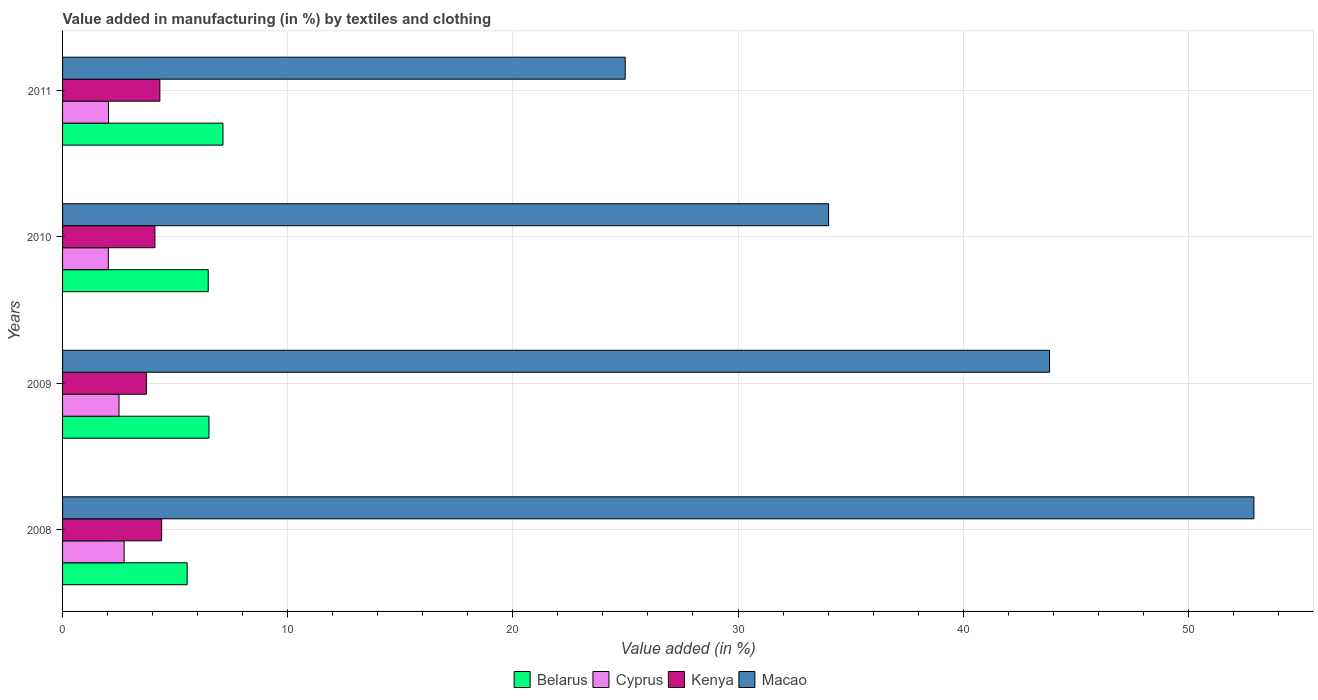How many different coloured bars are there?
Give a very brief answer. 4. Are the number of bars per tick equal to the number of legend labels?
Your response must be concise. Yes. What is the percentage of value added in manufacturing by textiles and clothing in Belarus in 2010?
Make the answer very short. 6.47. Across all years, what is the maximum percentage of value added in manufacturing by textiles and clothing in Kenya?
Your answer should be very brief. 4.4. Across all years, what is the minimum percentage of value added in manufacturing by textiles and clothing in Macao?
Offer a very short reply. 24.99. What is the total percentage of value added in manufacturing by textiles and clothing in Cyprus in the graph?
Your answer should be very brief. 9.31. What is the difference between the percentage of value added in manufacturing by textiles and clothing in Macao in 2009 and that in 2011?
Offer a terse response. 18.85. What is the difference between the percentage of value added in manufacturing by textiles and clothing in Macao in 2011 and the percentage of value added in manufacturing by textiles and clothing in Cyprus in 2008?
Offer a very short reply. 22.25. What is the average percentage of value added in manufacturing by textiles and clothing in Kenya per year?
Your response must be concise. 4.14. In the year 2010, what is the difference between the percentage of value added in manufacturing by textiles and clothing in Cyprus and percentage of value added in manufacturing by textiles and clothing in Macao?
Your answer should be very brief. -31.99. What is the ratio of the percentage of value added in manufacturing by textiles and clothing in Belarus in 2008 to that in 2010?
Ensure brevity in your answer.  0.86. Is the difference between the percentage of value added in manufacturing by textiles and clothing in Cyprus in 2010 and 2011 greater than the difference between the percentage of value added in manufacturing by textiles and clothing in Macao in 2010 and 2011?
Your answer should be compact. No. What is the difference between the highest and the second highest percentage of value added in manufacturing by textiles and clothing in Kenya?
Make the answer very short. 0.08. What is the difference between the highest and the lowest percentage of value added in manufacturing by textiles and clothing in Kenya?
Ensure brevity in your answer.  0.68. In how many years, is the percentage of value added in manufacturing by textiles and clothing in Cyprus greater than the average percentage of value added in manufacturing by textiles and clothing in Cyprus taken over all years?
Ensure brevity in your answer.  2. Is the sum of the percentage of value added in manufacturing by textiles and clothing in Kenya in 2010 and 2011 greater than the maximum percentage of value added in manufacturing by textiles and clothing in Belarus across all years?
Your answer should be very brief. Yes. What does the 4th bar from the top in 2010 represents?
Provide a short and direct response. Belarus. What does the 3rd bar from the bottom in 2010 represents?
Offer a very short reply. Kenya. Is it the case that in every year, the sum of the percentage of value added in manufacturing by textiles and clothing in Cyprus and percentage of value added in manufacturing by textiles and clothing in Macao is greater than the percentage of value added in manufacturing by textiles and clothing in Kenya?
Provide a succinct answer. Yes. How many years are there in the graph?
Your answer should be very brief. 4. What is the difference between two consecutive major ticks on the X-axis?
Offer a terse response. 10. Does the graph contain any zero values?
Offer a terse response. No. Does the graph contain grids?
Keep it short and to the point. Yes. Where does the legend appear in the graph?
Your response must be concise. Bottom center. How are the legend labels stacked?
Offer a terse response. Horizontal. What is the title of the graph?
Offer a very short reply. Value added in manufacturing (in %) by textiles and clothing. What is the label or title of the X-axis?
Provide a short and direct response. Value added (in %). What is the Value added (in %) of Belarus in 2008?
Keep it short and to the point. 5.53. What is the Value added (in %) of Cyprus in 2008?
Ensure brevity in your answer.  2.74. What is the Value added (in %) in Kenya in 2008?
Ensure brevity in your answer.  4.4. What is the Value added (in %) in Macao in 2008?
Ensure brevity in your answer.  52.92. What is the Value added (in %) of Belarus in 2009?
Give a very brief answer. 6.5. What is the Value added (in %) in Cyprus in 2009?
Your answer should be very brief. 2.51. What is the Value added (in %) of Kenya in 2009?
Offer a very short reply. 3.72. What is the Value added (in %) in Macao in 2009?
Make the answer very short. 43.84. What is the Value added (in %) of Belarus in 2010?
Your response must be concise. 6.47. What is the Value added (in %) of Cyprus in 2010?
Offer a very short reply. 2.03. What is the Value added (in %) in Kenya in 2010?
Keep it short and to the point. 4.1. What is the Value added (in %) of Macao in 2010?
Your answer should be compact. 34.02. What is the Value added (in %) of Belarus in 2011?
Your answer should be very brief. 7.12. What is the Value added (in %) in Cyprus in 2011?
Your response must be concise. 2.04. What is the Value added (in %) in Kenya in 2011?
Your answer should be compact. 4.32. What is the Value added (in %) in Macao in 2011?
Keep it short and to the point. 24.99. Across all years, what is the maximum Value added (in %) of Belarus?
Ensure brevity in your answer.  7.12. Across all years, what is the maximum Value added (in %) of Cyprus?
Offer a terse response. 2.74. Across all years, what is the maximum Value added (in %) of Kenya?
Ensure brevity in your answer.  4.4. Across all years, what is the maximum Value added (in %) of Macao?
Offer a very short reply. 52.92. Across all years, what is the minimum Value added (in %) in Belarus?
Your answer should be very brief. 5.53. Across all years, what is the minimum Value added (in %) of Cyprus?
Keep it short and to the point. 2.03. Across all years, what is the minimum Value added (in %) in Kenya?
Keep it short and to the point. 3.72. Across all years, what is the minimum Value added (in %) of Macao?
Offer a very short reply. 24.99. What is the total Value added (in %) in Belarus in the graph?
Make the answer very short. 25.63. What is the total Value added (in %) in Cyprus in the graph?
Provide a succinct answer. 9.31. What is the total Value added (in %) of Kenya in the graph?
Keep it short and to the point. 16.55. What is the total Value added (in %) of Macao in the graph?
Keep it short and to the point. 155.77. What is the difference between the Value added (in %) in Belarus in 2008 and that in 2009?
Provide a short and direct response. -0.97. What is the difference between the Value added (in %) of Cyprus in 2008 and that in 2009?
Provide a short and direct response. 0.23. What is the difference between the Value added (in %) in Kenya in 2008 and that in 2009?
Ensure brevity in your answer.  0.68. What is the difference between the Value added (in %) in Macao in 2008 and that in 2009?
Ensure brevity in your answer.  9.08. What is the difference between the Value added (in %) of Belarus in 2008 and that in 2010?
Make the answer very short. -0.94. What is the difference between the Value added (in %) of Cyprus in 2008 and that in 2010?
Your answer should be very brief. 0.7. What is the difference between the Value added (in %) of Kenya in 2008 and that in 2010?
Make the answer very short. 0.3. What is the difference between the Value added (in %) of Macao in 2008 and that in 2010?
Your response must be concise. 18.89. What is the difference between the Value added (in %) of Belarus in 2008 and that in 2011?
Make the answer very short. -1.59. What is the difference between the Value added (in %) in Cyprus in 2008 and that in 2011?
Provide a short and direct response. 0.69. What is the difference between the Value added (in %) of Kenya in 2008 and that in 2011?
Your answer should be compact. 0.08. What is the difference between the Value added (in %) of Macao in 2008 and that in 2011?
Your answer should be very brief. 27.93. What is the difference between the Value added (in %) of Belarus in 2009 and that in 2010?
Ensure brevity in your answer.  0.03. What is the difference between the Value added (in %) of Cyprus in 2009 and that in 2010?
Ensure brevity in your answer.  0.48. What is the difference between the Value added (in %) in Kenya in 2009 and that in 2010?
Make the answer very short. -0.38. What is the difference between the Value added (in %) in Macao in 2009 and that in 2010?
Provide a short and direct response. 9.82. What is the difference between the Value added (in %) of Belarus in 2009 and that in 2011?
Ensure brevity in your answer.  -0.62. What is the difference between the Value added (in %) in Cyprus in 2009 and that in 2011?
Your response must be concise. 0.47. What is the difference between the Value added (in %) in Kenya in 2009 and that in 2011?
Keep it short and to the point. -0.6. What is the difference between the Value added (in %) of Macao in 2009 and that in 2011?
Make the answer very short. 18.85. What is the difference between the Value added (in %) of Belarus in 2010 and that in 2011?
Ensure brevity in your answer.  -0.66. What is the difference between the Value added (in %) of Cyprus in 2010 and that in 2011?
Offer a terse response. -0.01. What is the difference between the Value added (in %) in Kenya in 2010 and that in 2011?
Offer a very short reply. -0.22. What is the difference between the Value added (in %) in Macao in 2010 and that in 2011?
Offer a terse response. 9.03. What is the difference between the Value added (in %) of Belarus in 2008 and the Value added (in %) of Cyprus in 2009?
Ensure brevity in your answer.  3.03. What is the difference between the Value added (in %) of Belarus in 2008 and the Value added (in %) of Kenya in 2009?
Your response must be concise. 1.81. What is the difference between the Value added (in %) in Belarus in 2008 and the Value added (in %) in Macao in 2009?
Provide a short and direct response. -38.31. What is the difference between the Value added (in %) of Cyprus in 2008 and the Value added (in %) of Kenya in 2009?
Your response must be concise. -0.99. What is the difference between the Value added (in %) of Cyprus in 2008 and the Value added (in %) of Macao in 2009?
Offer a very short reply. -41.1. What is the difference between the Value added (in %) in Kenya in 2008 and the Value added (in %) in Macao in 2009?
Ensure brevity in your answer.  -39.44. What is the difference between the Value added (in %) in Belarus in 2008 and the Value added (in %) in Cyprus in 2010?
Give a very brief answer. 3.5. What is the difference between the Value added (in %) of Belarus in 2008 and the Value added (in %) of Kenya in 2010?
Ensure brevity in your answer.  1.43. What is the difference between the Value added (in %) of Belarus in 2008 and the Value added (in %) of Macao in 2010?
Keep it short and to the point. -28.49. What is the difference between the Value added (in %) in Cyprus in 2008 and the Value added (in %) in Kenya in 2010?
Give a very brief answer. -1.37. What is the difference between the Value added (in %) of Cyprus in 2008 and the Value added (in %) of Macao in 2010?
Provide a succinct answer. -31.29. What is the difference between the Value added (in %) of Kenya in 2008 and the Value added (in %) of Macao in 2010?
Provide a succinct answer. -29.62. What is the difference between the Value added (in %) in Belarus in 2008 and the Value added (in %) in Cyprus in 2011?
Offer a terse response. 3.49. What is the difference between the Value added (in %) in Belarus in 2008 and the Value added (in %) in Kenya in 2011?
Offer a very short reply. 1.21. What is the difference between the Value added (in %) of Belarus in 2008 and the Value added (in %) of Macao in 2011?
Your response must be concise. -19.46. What is the difference between the Value added (in %) in Cyprus in 2008 and the Value added (in %) in Kenya in 2011?
Provide a succinct answer. -1.59. What is the difference between the Value added (in %) of Cyprus in 2008 and the Value added (in %) of Macao in 2011?
Provide a succinct answer. -22.25. What is the difference between the Value added (in %) of Kenya in 2008 and the Value added (in %) of Macao in 2011?
Ensure brevity in your answer.  -20.59. What is the difference between the Value added (in %) in Belarus in 2009 and the Value added (in %) in Cyprus in 2010?
Offer a terse response. 4.47. What is the difference between the Value added (in %) of Belarus in 2009 and the Value added (in %) of Kenya in 2010?
Your response must be concise. 2.4. What is the difference between the Value added (in %) in Belarus in 2009 and the Value added (in %) in Macao in 2010?
Your answer should be compact. -27.52. What is the difference between the Value added (in %) in Cyprus in 2009 and the Value added (in %) in Kenya in 2010?
Provide a short and direct response. -1.59. What is the difference between the Value added (in %) of Cyprus in 2009 and the Value added (in %) of Macao in 2010?
Offer a very short reply. -31.52. What is the difference between the Value added (in %) of Kenya in 2009 and the Value added (in %) of Macao in 2010?
Offer a very short reply. -30.3. What is the difference between the Value added (in %) in Belarus in 2009 and the Value added (in %) in Cyprus in 2011?
Ensure brevity in your answer.  4.46. What is the difference between the Value added (in %) of Belarus in 2009 and the Value added (in %) of Kenya in 2011?
Offer a terse response. 2.18. What is the difference between the Value added (in %) in Belarus in 2009 and the Value added (in %) in Macao in 2011?
Your answer should be very brief. -18.49. What is the difference between the Value added (in %) of Cyprus in 2009 and the Value added (in %) of Kenya in 2011?
Your answer should be compact. -1.81. What is the difference between the Value added (in %) in Cyprus in 2009 and the Value added (in %) in Macao in 2011?
Provide a short and direct response. -22.48. What is the difference between the Value added (in %) in Kenya in 2009 and the Value added (in %) in Macao in 2011?
Your answer should be very brief. -21.27. What is the difference between the Value added (in %) in Belarus in 2010 and the Value added (in %) in Cyprus in 2011?
Offer a very short reply. 4.43. What is the difference between the Value added (in %) of Belarus in 2010 and the Value added (in %) of Kenya in 2011?
Make the answer very short. 2.15. What is the difference between the Value added (in %) in Belarus in 2010 and the Value added (in %) in Macao in 2011?
Ensure brevity in your answer.  -18.52. What is the difference between the Value added (in %) of Cyprus in 2010 and the Value added (in %) of Kenya in 2011?
Offer a terse response. -2.29. What is the difference between the Value added (in %) in Cyprus in 2010 and the Value added (in %) in Macao in 2011?
Your answer should be very brief. -22.96. What is the difference between the Value added (in %) of Kenya in 2010 and the Value added (in %) of Macao in 2011?
Offer a very short reply. -20.89. What is the average Value added (in %) in Belarus per year?
Your response must be concise. 6.41. What is the average Value added (in %) of Cyprus per year?
Make the answer very short. 2.33. What is the average Value added (in %) in Kenya per year?
Give a very brief answer. 4.14. What is the average Value added (in %) of Macao per year?
Your answer should be very brief. 38.94. In the year 2008, what is the difference between the Value added (in %) of Belarus and Value added (in %) of Cyprus?
Offer a very short reply. 2.8. In the year 2008, what is the difference between the Value added (in %) of Belarus and Value added (in %) of Kenya?
Keep it short and to the point. 1.13. In the year 2008, what is the difference between the Value added (in %) of Belarus and Value added (in %) of Macao?
Make the answer very short. -47.38. In the year 2008, what is the difference between the Value added (in %) in Cyprus and Value added (in %) in Kenya?
Your response must be concise. -1.67. In the year 2008, what is the difference between the Value added (in %) in Cyprus and Value added (in %) in Macao?
Make the answer very short. -50.18. In the year 2008, what is the difference between the Value added (in %) in Kenya and Value added (in %) in Macao?
Keep it short and to the point. -48.51. In the year 2009, what is the difference between the Value added (in %) in Belarus and Value added (in %) in Cyprus?
Your answer should be compact. 4. In the year 2009, what is the difference between the Value added (in %) in Belarus and Value added (in %) in Kenya?
Give a very brief answer. 2.78. In the year 2009, what is the difference between the Value added (in %) of Belarus and Value added (in %) of Macao?
Ensure brevity in your answer.  -37.34. In the year 2009, what is the difference between the Value added (in %) of Cyprus and Value added (in %) of Kenya?
Ensure brevity in your answer.  -1.22. In the year 2009, what is the difference between the Value added (in %) in Cyprus and Value added (in %) in Macao?
Offer a terse response. -41.33. In the year 2009, what is the difference between the Value added (in %) in Kenya and Value added (in %) in Macao?
Ensure brevity in your answer.  -40.12. In the year 2010, what is the difference between the Value added (in %) of Belarus and Value added (in %) of Cyprus?
Provide a succinct answer. 4.44. In the year 2010, what is the difference between the Value added (in %) of Belarus and Value added (in %) of Kenya?
Your response must be concise. 2.37. In the year 2010, what is the difference between the Value added (in %) in Belarus and Value added (in %) in Macao?
Keep it short and to the point. -27.55. In the year 2010, what is the difference between the Value added (in %) in Cyprus and Value added (in %) in Kenya?
Provide a short and direct response. -2.07. In the year 2010, what is the difference between the Value added (in %) of Cyprus and Value added (in %) of Macao?
Your answer should be compact. -31.99. In the year 2010, what is the difference between the Value added (in %) in Kenya and Value added (in %) in Macao?
Offer a terse response. -29.92. In the year 2011, what is the difference between the Value added (in %) of Belarus and Value added (in %) of Cyprus?
Offer a very short reply. 5.08. In the year 2011, what is the difference between the Value added (in %) of Belarus and Value added (in %) of Kenya?
Ensure brevity in your answer.  2.8. In the year 2011, what is the difference between the Value added (in %) in Belarus and Value added (in %) in Macao?
Your answer should be very brief. -17.87. In the year 2011, what is the difference between the Value added (in %) in Cyprus and Value added (in %) in Kenya?
Give a very brief answer. -2.28. In the year 2011, what is the difference between the Value added (in %) of Cyprus and Value added (in %) of Macao?
Offer a very short reply. -22.95. In the year 2011, what is the difference between the Value added (in %) in Kenya and Value added (in %) in Macao?
Offer a terse response. -20.67. What is the ratio of the Value added (in %) in Belarus in 2008 to that in 2009?
Your answer should be very brief. 0.85. What is the ratio of the Value added (in %) in Cyprus in 2008 to that in 2009?
Provide a succinct answer. 1.09. What is the ratio of the Value added (in %) of Kenya in 2008 to that in 2009?
Your answer should be very brief. 1.18. What is the ratio of the Value added (in %) of Macao in 2008 to that in 2009?
Provide a succinct answer. 1.21. What is the ratio of the Value added (in %) of Belarus in 2008 to that in 2010?
Keep it short and to the point. 0.86. What is the ratio of the Value added (in %) in Cyprus in 2008 to that in 2010?
Keep it short and to the point. 1.35. What is the ratio of the Value added (in %) in Kenya in 2008 to that in 2010?
Provide a succinct answer. 1.07. What is the ratio of the Value added (in %) of Macao in 2008 to that in 2010?
Give a very brief answer. 1.56. What is the ratio of the Value added (in %) of Belarus in 2008 to that in 2011?
Make the answer very short. 0.78. What is the ratio of the Value added (in %) of Cyprus in 2008 to that in 2011?
Provide a short and direct response. 1.34. What is the ratio of the Value added (in %) of Kenya in 2008 to that in 2011?
Your answer should be compact. 1.02. What is the ratio of the Value added (in %) in Macao in 2008 to that in 2011?
Your response must be concise. 2.12. What is the ratio of the Value added (in %) in Belarus in 2009 to that in 2010?
Keep it short and to the point. 1.01. What is the ratio of the Value added (in %) of Cyprus in 2009 to that in 2010?
Offer a very short reply. 1.23. What is the ratio of the Value added (in %) in Kenya in 2009 to that in 2010?
Provide a short and direct response. 0.91. What is the ratio of the Value added (in %) in Macao in 2009 to that in 2010?
Ensure brevity in your answer.  1.29. What is the ratio of the Value added (in %) in Belarus in 2009 to that in 2011?
Give a very brief answer. 0.91. What is the ratio of the Value added (in %) in Cyprus in 2009 to that in 2011?
Provide a succinct answer. 1.23. What is the ratio of the Value added (in %) in Kenya in 2009 to that in 2011?
Give a very brief answer. 0.86. What is the ratio of the Value added (in %) in Macao in 2009 to that in 2011?
Ensure brevity in your answer.  1.75. What is the ratio of the Value added (in %) of Belarus in 2010 to that in 2011?
Offer a terse response. 0.91. What is the ratio of the Value added (in %) in Cyprus in 2010 to that in 2011?
Make the answer very short. 1. What is the ratio of the Value added (in %) of Kenya in 2010 to that in 2011?
Ensure brevity in your answer.  0.95. What is the ratio of the Value added (in %) of Macao in 2010 to that in 2011?
Offer a terse response. 1.36. What is the difference between the highest and the second highest Value added (in %) in Belarus?
Keep it short and to the point. 0.62. What is the difference between the highest and the second highest Value added (in %) in Cyprus?
Provide a succinct answer. 0.23. What is the difference between the highest and the second highest Value added (in %) in Kenya?
Your answer should be very brief. 0.08. What is the difference between the highest and the second highest Value added (in %) in Macao?
Offer a very short reply. 9.08. What is the difference between the highest and the lowest Value added (in %) in Belarus?
Your answer should be compact. 1.59. What is the difference between the highest and the lowest Value added (in %) in Cyprus?
Provide a succinct answer. 0.7. What is the difference between the highest and the lowest Value added (in %) in Kenya?
Your response must be concise. 0.68. What is the difference between the highest and the lowest Value added (in %) in Macao?
Your answer should be compact. 27.93. 